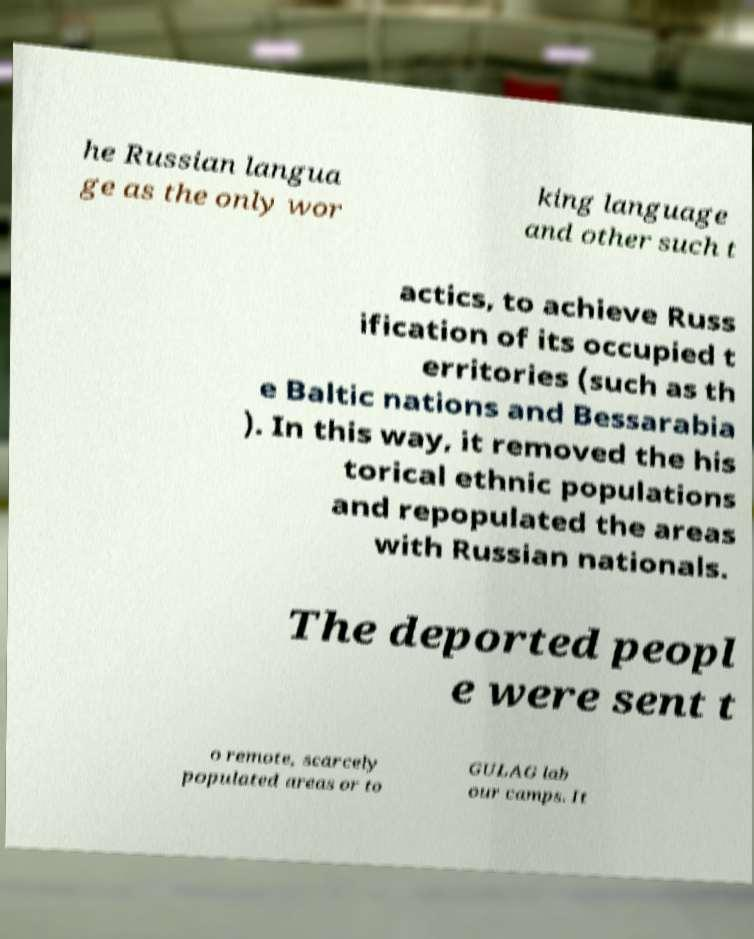For documentation purposes, I need the text within this image transcribed. Could you provide that? he Russian langua ge as the only wor king language and other such t actics, to achieve Russ ification of its occupied t erritories (such as th e Baltic nations and Bessarabia ). In this way, it removed the his torical ethnic populations and repopulated the areas with Russian nationals. The deported peopl e were sent t o remote, scarcely populated areas or to GULAG lab our camps. It 